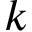Convert formula to latex. <formula><loc_0><loc_0><loc_500><loc_500>k</formula> 